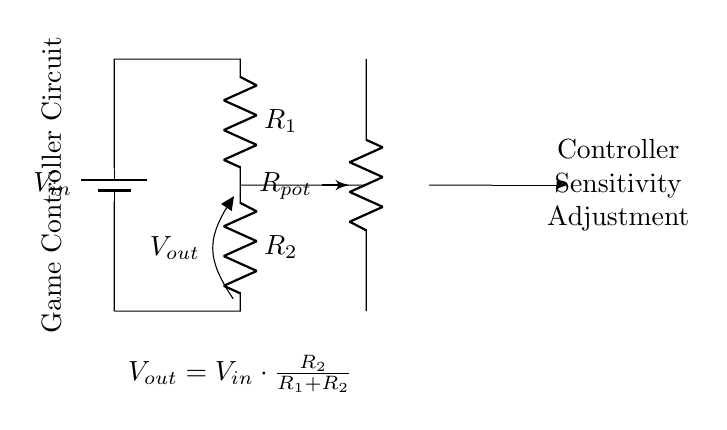What is the input voltage denoted as? The input voltage is denoted as V in, which is labeled on the battery in the circuit diagram.
Answer: V in What are the resistances present in this circuit? The circuit contains two fixed resistors labeled R1 and R2, and one variable resistor labeled Rpot (potentiometer).
Answer: R1, R2, Rpot What is the output voltage formula? The output voltage V out is expressed by the formula V out = V in * (R2 / (R1 + R2)), as shown in the circuit diagram.
Answer: V out = V in * (R2 / (R1 + R2)) How does adjusting the potentiometer affect the output voltage? Adjusting the potentiometer Rpot varies the resistance in the circuit, which in turn affects the division of voltage between R1 and R2, thus altering V out.
Answer: V out changes What type of circuit configuration is this? The circuit is a voltage divider configuration, as it splits the input voltage into smaller output voltages based on the resistances.
Answer: Voltage divider At what point is the output voltage measured? The output voltage V out is measured across R2, which is indicated in the circuit diagram by the label on R2.
Answer: Across R2 